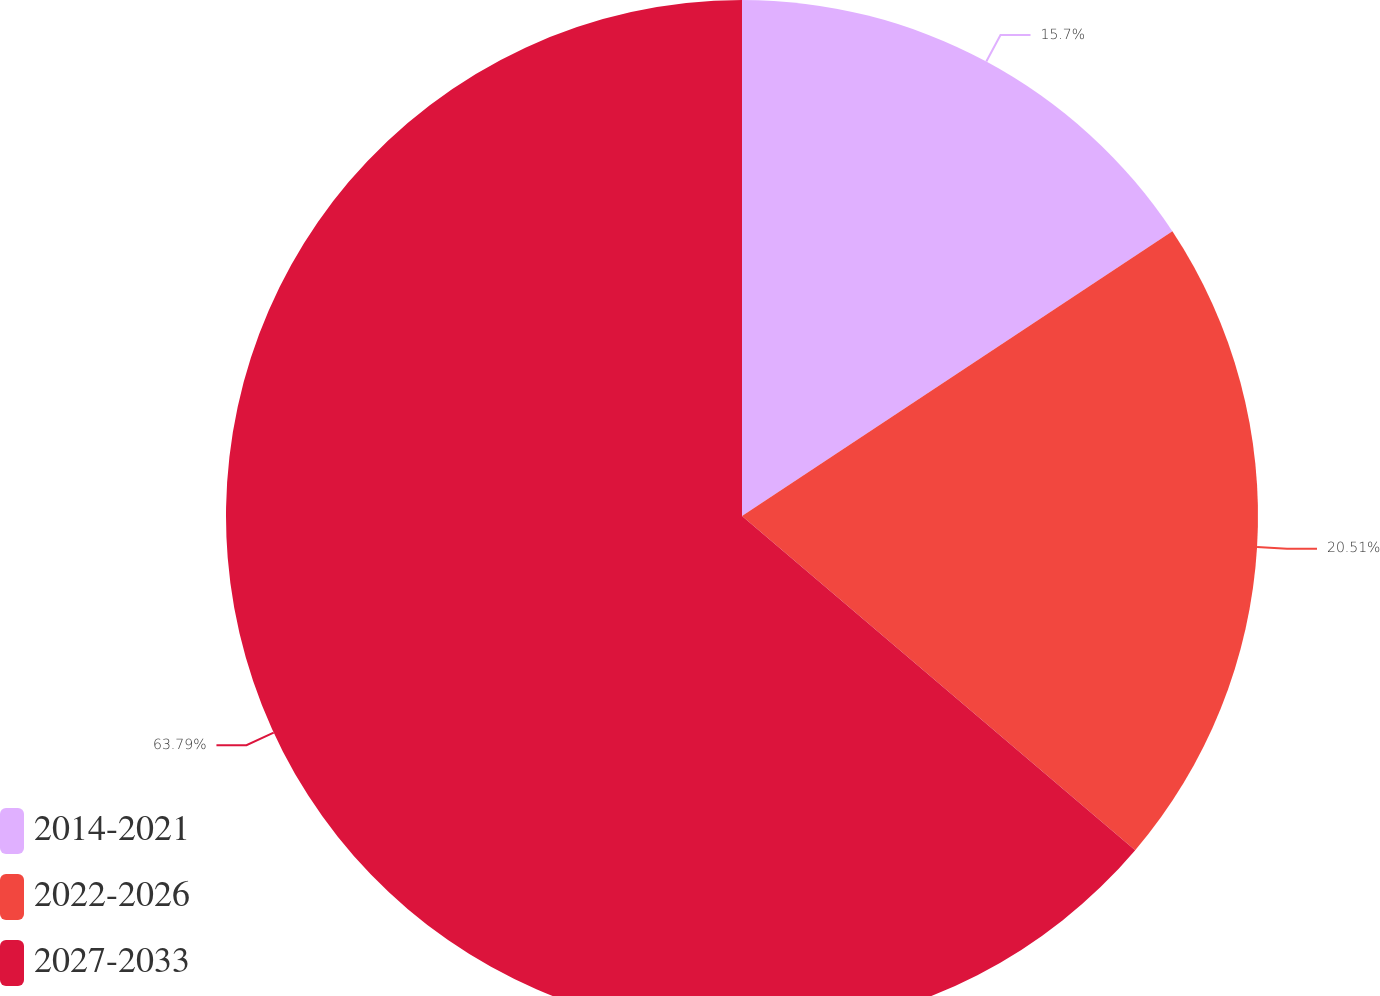Convert chart to OTSL. <chart><loc_0><loc_0><loc_500><loc_500><pie_chart><fcel>2014-2021<fcel>2022-2026<fcel>2027-2033<nl><fcel>15.7%<fcel>20.51%<fcel>63.79%<nl></chart> 